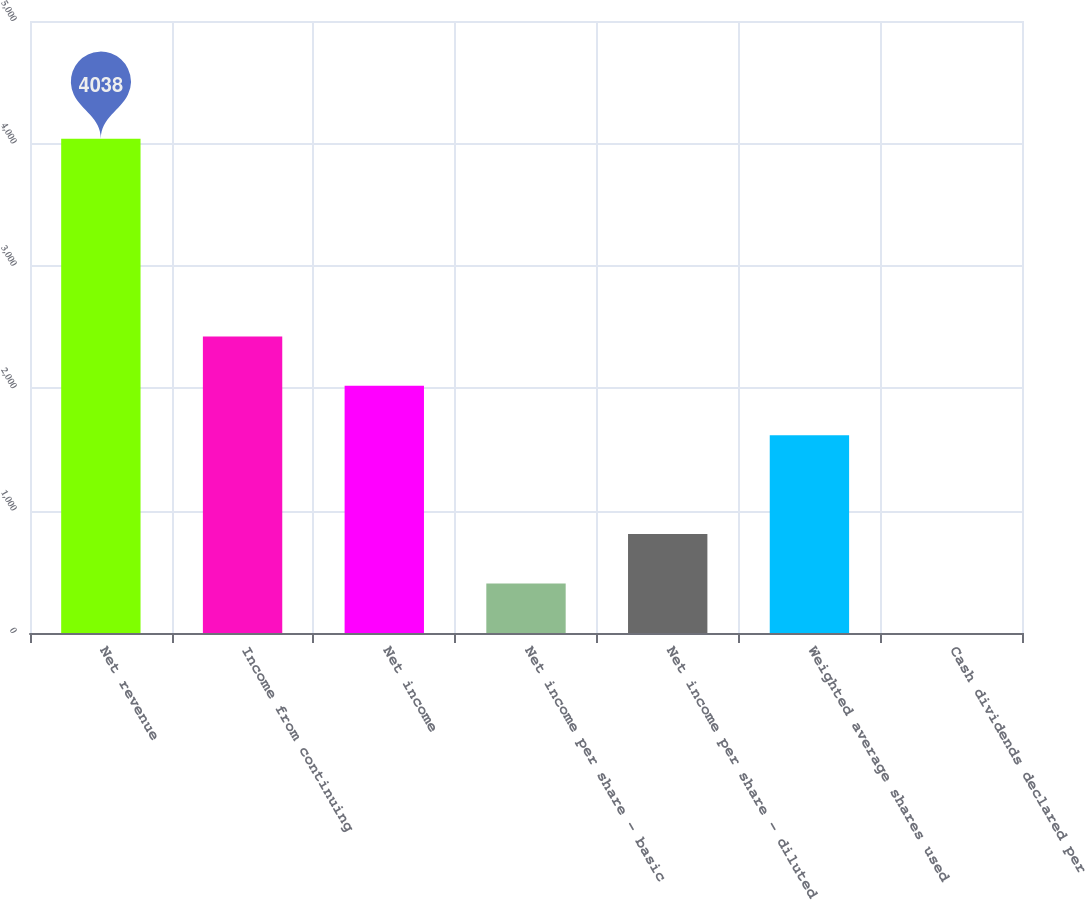<chart> <loc_0><loc_0><loc_500><loc_500><bar_chart><fcel>Net revenue<fcel>Income from continuing<fcel>Net income<fcel>Net income per share - basic<fcel>Net income per share - diluted<fcel>Weighted average shares used<fcel>Cash dividends declared per<nl><fcel>4038<fcel>2422.96<fcel>2019.2<fcel>404.16<fcel>807.92<fcel>1615.44<fcel>0.4<nl></chart> 